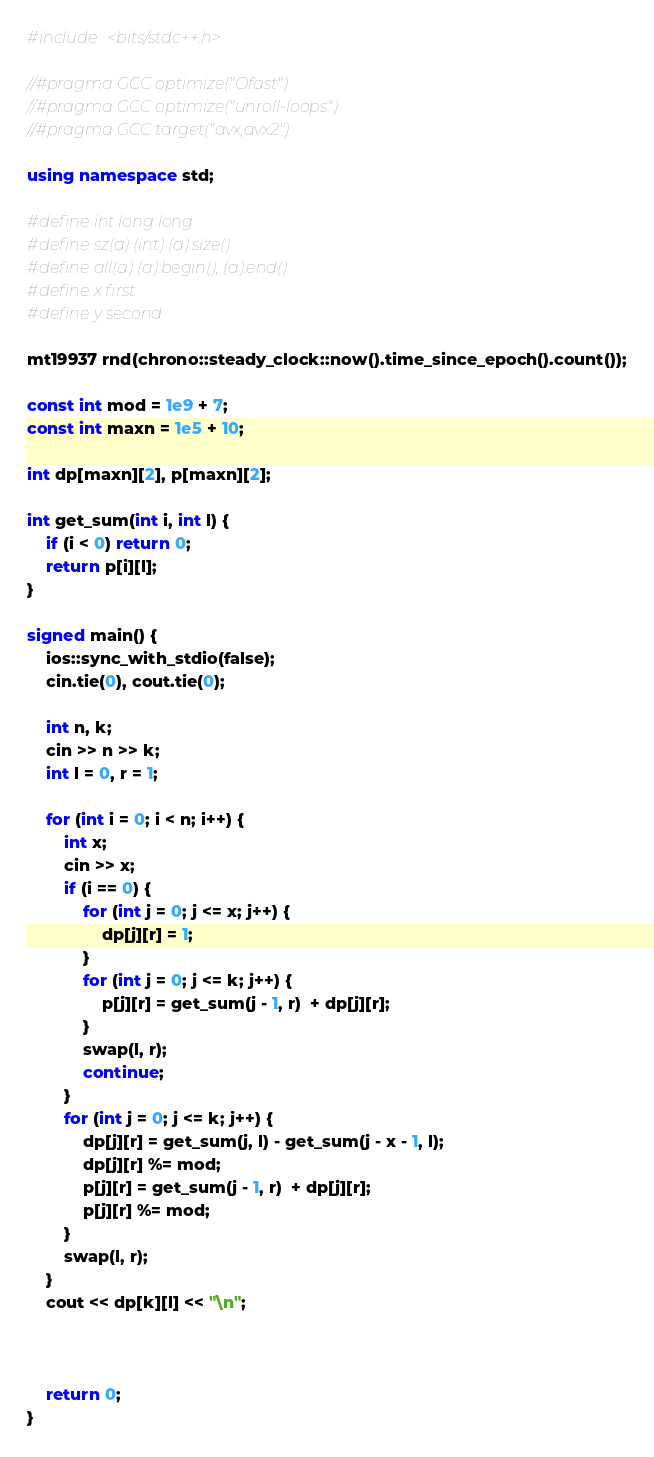<code> <loc_0><loc_0><loc_500><loc_500><_C++_>#include <bits/stdc++.h>

//#pragma GCC optimize("Ofast")
//#pragma GCC optimize("unroll-loops")
//#pragma GCC target("avx,avx2")

using namespace std;

#define int long long
#define sz(a) (int) (a).size()
#define all(a) (a).begin(), (a).end()
#define x first
#define y second

mt19937 rnd(chrono::steady_clock::now().time_since_epoch().count());

const int mod = 1e9 + 7;
const int maxn = 1e5 + 10;

int dp[maxn][2], p[maxn][2];

int get_sum(int i, int l) {
    if (i < 0) return 0;
    return p[i][l];
}

signed main() {
    ios::sync_with_stdio(false);
    cin.tie(0), cout.tie(0);

    int n, k;
    cin >> n >> k;
    int l = 0, r = 1;

    for (int i = 0; i < n; i++) {
        int x;
        cin >> x;
        if (i == 0) {
            for (int j = 0; j <= x; j++) {
                dp[j][r] = 1;
            }
            for (int j = 0; j <= k; j++) {
                p[j][r] = get_sum(j - 1, r)  + dp[j][r];
            }
            swap(l, r);
            continue;
        }
        for (int j = 0; j <= k; j++) {
            dp[j][r] = get_sum(j, l) - get_sum(j - x - 1, l);
            dp[j][r] %= mod;
            p[j][r] = get_sum(j - 1, r)  + dp[j][r];
            p[j][r] %= mod;
        }
        swap(l, r);
    }
    cout << dp[k][l] << "\n";



    return 0;
}</code> 